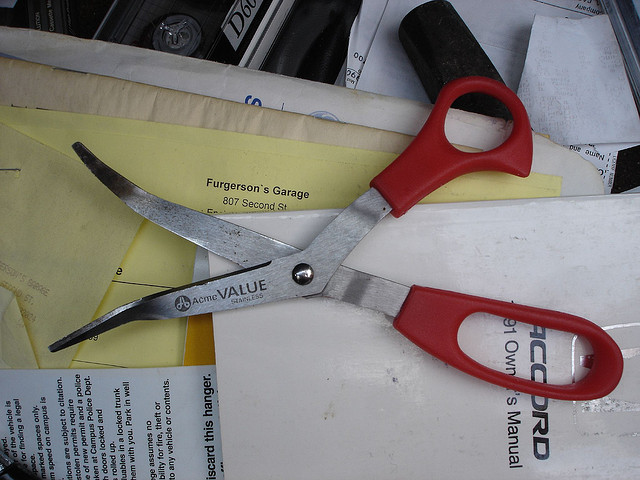<image>Which writing is handwritten? There is no handwritten writing in the image. What is the address of Furgerson's Garage? It is uncertain what is the exact address of Furgerson's Garage, it might be '807 second st' or '817 second st'. Which writing is handwritten? All writings are typed. There is no handwritten writing. What is the address of Furgerson's Garage? I am not sure about the address of Furgerson's Garage. It can be '807 second st', '817 second st', '807 second rd', '807 2nd st' or '607 selling rd'. 